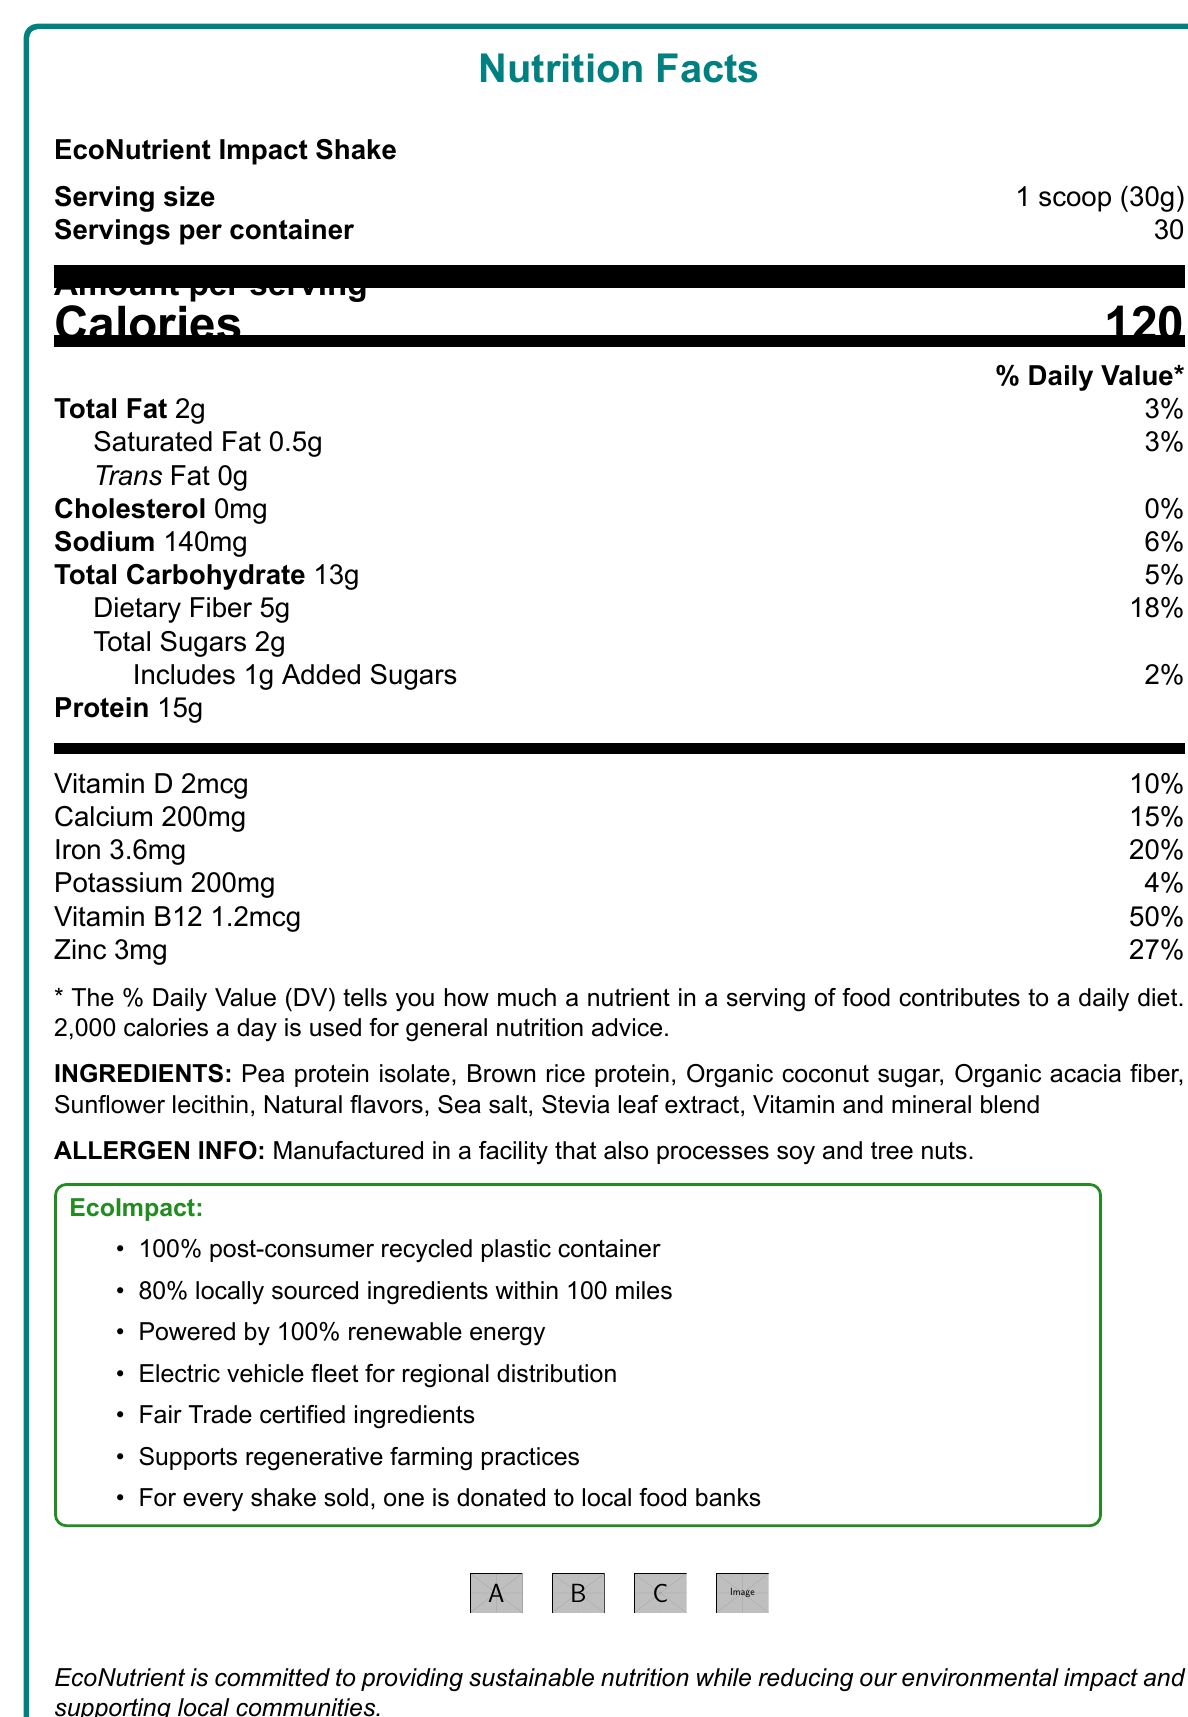what is the serving size? The serving size is directly mentioned in the document under "Serving size."
Answer: 1 scoop (30g) how many servings are in one container? The document states "Servings per container" as 30.
Answer: 30 what is the amount of dietary fiber per serving? The document specifies "Dietary Fiber" as 5g per serving.
Answer: 5g what percentage of daily value does the iron content provide? The document lists the daily value for iron as 20%.
Answer: 20% what allergen information is provided? The allergen information is clearly stated in the document under "ALLERGEN INFO."
Answer: Manufactured in a facility that also processes soy and tree nuts. what are the sources of protein in this product? The protein sources are listed in the ingredients section of the document.
Answer: Pea protein isolate, Brown rice protein how many grams of total sugars are in one serving? This information is found under "Total Sugars" in the nutritional facts.
Answer: 2g what type of container is used for this product? A. Glass B. Post-consumer recycled plastic C. Paperboard The document states the packaging is "100% post-consumer recycled plastic container."
Answer: B. Post-consumer recycled plastic how is the manufacturing of this product powered? A. Solar energy B. Wind energy C. Renewable energy D. Fossil fuels The document mentions "Powered by 100% renewable energy."
Answer: C. Renewable energy does the product use locally sourced ingredients? The document mentions that 80% of the ingredients are locally sourced within 100 miles.
Answer: Yes describe the mission of EcoNutrient The mission statement is clearly included at the end of the document.
Answer: EcoNutrient is committed to providing sustainable nutrition while reducing our environmental impact and supporting local communities. what is the daily value percentage for vitamin B12? The daily value percentage for vitamin B12 is 50%, as stated in the nutritional breakdown.
Answer: 50% how many certifications does this product have? The document lists four certifications: USDA Organic, Non-GMO Project Verified, B Corporation Certified, and Carbon Neutral Certified.
Answer: 4 how many calories are in one serving? The document specifies that there are 120 calories per serving.
Answer: 120 what is the added sugars daily value percentage? The daily value percentage for added sugars is listed as 2% in the document.
Answer: 2% what information about regenerative agriculture is provided? The document mentions that the product supports regenerative farming practices under the social impact section.
Answer: Supports regenerative farming practices does this product contain any trans fat? The document states that the trans fat content is 0g per serving.
Answer: No which of these ingredients is NOT in the product? A. Organic acacia fiber B. Whey protein C. Stevia leaf extract D. Sea salt The ingredients list does not include whey protein, while the other options are mentioned.
Answer: B. Whey protein is the product's sodium content more than 200mg per serving? The document shows the sodium content as 140mg per serving, which is less than 200mg.
Answer: No what does the company donate with each sale? The EcoImpact section mentions that for every shake sold, one is donated to local food banks.
Answer: One shake to local food banks what is the total fat content per serving? The document lists the total fat content as 2g per serving.
Answer: 2g how much calcium is in one serving? The nutritional facts section lists calcium as 200mg per serving.
Answer: 200mg which certifications ensure the product’s ecological impact? A. USDA Organic B. B Corporation Certified C. Non-GMO Project Verified D. All of the above All these certifications mentioned in the document indicate the product's ecological impact.
Answer: D. All of the above which factor CANNOT be determined from this document? This document does not provide any pricing information.
Answer: The cost of the product does the product use electric vehicles for distribution? The document mentions the use of an electric vehicle fleet for regional distribution under carbon footprint reduction.
Answer: Yes 